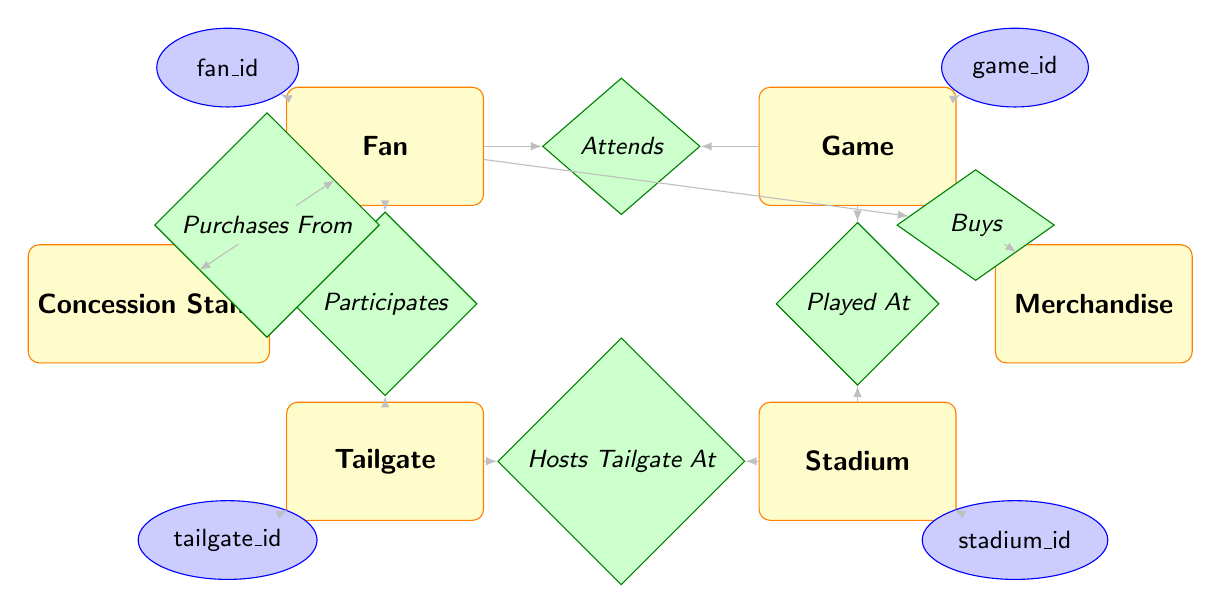What is the relationship between Fan and Game? The diagram indicates that a "Fan" attends a "Game," confirmed by the "Attends" relationship connecting both entities.
Answer: Attends How many entities are represented in the diagram? By counting the distinct rectangles representing the entities, including Fan, Tailgate, Game, Stadium, Concession Stand, and Merchandise, we find that there are six entities in total.
Answer: 6 What attributes does the Tailgate entity have? The attributes of the Tailgate entity, as listed within the Tailgate rectangle, are tailgate_id, location, and start_time.
Answer: tailgate_id, location, start_time Which entity is connected to the Concession Stand? The relationship "Purchases From" indicates that a "Fan" is connected to a "Concession Stand," showing that fans buy from concession stands during the game day experience.
Answer: Fan What is the primary function of the Hosts Tailgate At relationship? The "Hosts Tailgate At" relationship clarifies that it connects the "Tailgate" entity to the "Stadium," which indicates that tailgating occurs at a specific stadium location.
Answer: Connects Tailgate and Stadium Which entity has the attribute stadium_id? The diagram shows that the "Stadium" entity includes the attribute stadium_id, which uniquely identifies each stadium within the context of the game day experience.
Answer: Stadium How many relationships involve the Fan entity? By analyzing the lines connecting to the "Fan" entity, we see that it connects with three relationships: "Attends," "Participates," and "Purchases From," totaling three relationships involving the Fan.
Answer: 3 What is the main role of the Merchandise entity in the diagram? The "Merchandise" entity is associated with the "Buys" relationship, which shows that a Fan can purchase merchandise, indicating that it plays a role in the shopping aspect of the game day experience.
Answer: Buys Which relationship connects the Game and Stadium entities? The "Played At" relationship links the Game and Stadium entities, which signifies that each game is hosted at a specific stadium.
Answer: Played At 